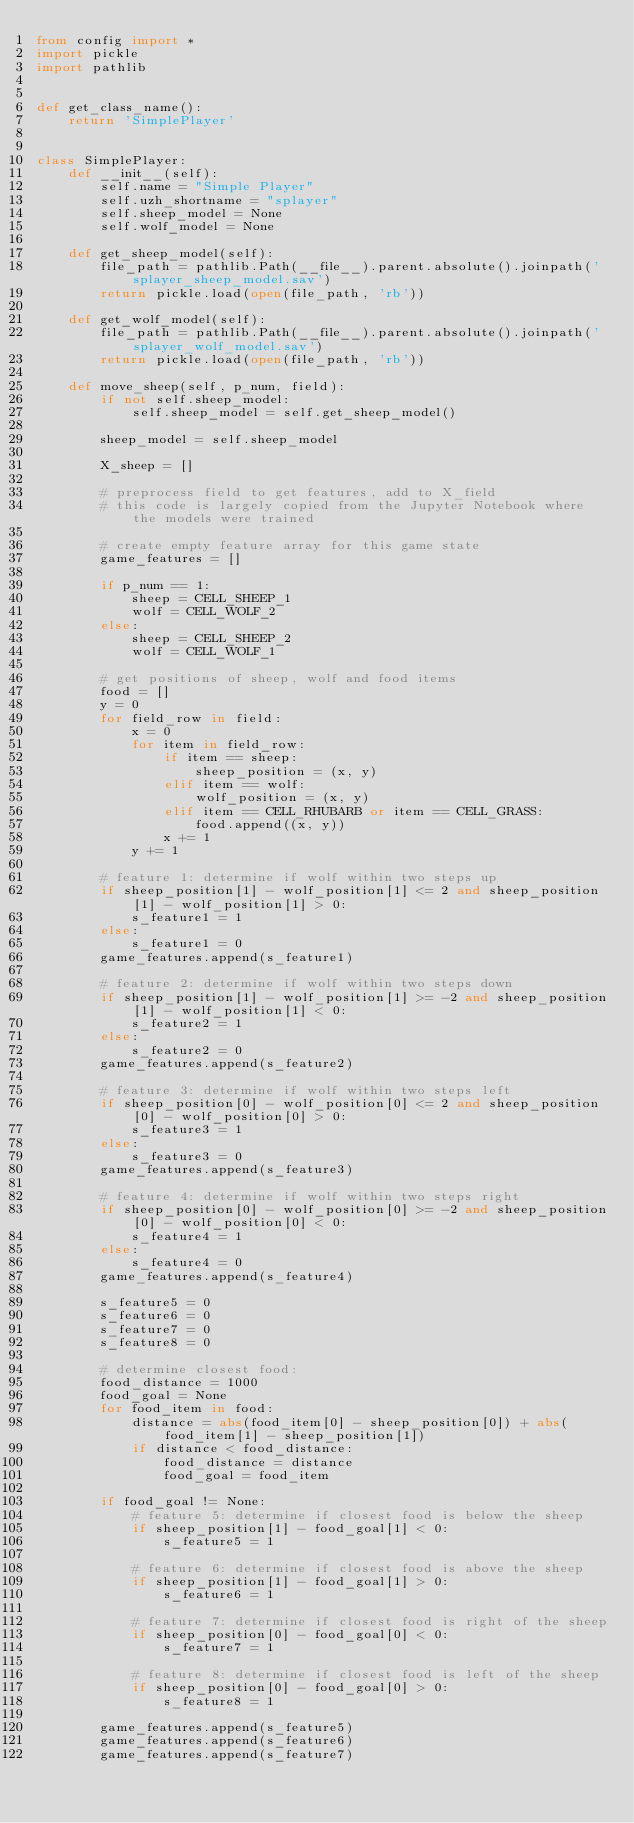Convert code to text. <code><loc_0><loc_0><loc_500><loc_500><_Python_>from config import *
import pickle
import pathlib


def get_class_name():
    return 'SimplePlayer'


class SimplePlayer:
    def __init__(self):
        self.name = "Simple Player"
        self.uzh_shortname = "splayer"
        self.sheep_model = None
        self.wolf_model = None

    def get_sheep_model(self):
        file_path = pathlib.Path(__file__).parent.absolute().joinpath('splayer_sheep_model.sav')
        return pickle.load(open(file_path, 'rb'))

    def get_wolf_model(self):
        file_path = pathlib.Path(__file__).parent.absolute().joinpath('splayer_wolf_model.sav')
        return pickle.load(open(file_path, 'rb'))

    def move_sheep(self, p_num, field):
        if not self.sheep_model:
            self.sheep_model = self.get_sheep_model()

        sheep_model = self.sheep_model

        X_sheep = []

        # preprocess field to get features, add to X_field
        # this code is largely copied from the Jupyter Notebook where the models were trained

        # create empty feature array for this game state
        game_features = []

        if p_num == 1:
            sheep = CELL_SHEEP_1
            wolf = CELL_WOLF_2
        else:
            sheep = CELL_SHEEP_2
            wolf = CELL_WOLF_1

        # get positions of sheep, wolf and food items
        food = []
        y = 0
        for field_row in field:
            x = 0
            for item in field_row:
                if item == sheep:
                    sheep_position = (x, y)
                elif item == wolf:
                    wolf_position = (x, y)
                elif item == CELL_RHUBARB or item == CELL_GRASS:
                    food.append((x, y))
                x += 1
            y += 1

        # feature 1: determine if wolf within two steps up
        if sheep_position[1] - wolf_position[1] <= 2 and sheep_position[1] - wolf_position[1] > 0:
            s_feature1 = 1
        else:
            s_feature1 = 0
        game_features.append(s_feature1)

        # feature 2: determine if wolf within two steps down
        if sheep_position[1] - wolf_position[1] >= -2 and sheep_position[1] - wolf_position[1] < 0:
            s_feature2 = 1
        else:
            s_feature2 = 0
        game_features.append(s_feature2)

        # feature 3: determine if wolf within two steps left
        if sheep_position[0] - wolf_position[0] <= 2 and sheep_position[0] - wolf_position[0] > 0:
            s_feature3 = 1
        else:
            s_feature3 = 0
        game_features.append(s_feature3)

        # feature 4: determine if wolf within two steps right
        if sheep_position[0] - wolf_position[0] >= -2 and sheep_position[0] - wolf_position[0] < 0:
            s_feature4 = 1
        else:
            s_feature4 = 0
        game_features.append(s_feature4)

        s_feature5 = 0
        s_feature6 = 0
        s_feature7 = 0
        s_feature8 = 0

        # determine closest food:
        food_distance = 1000
        food_goal = None
        for food_item in food:
            distance = abs(food_item[0] - sheep_position[0]) + abs(food_item[1] - sheep_position[1])
            if distance < food_distance:
                food_distance = distance
                food_goal = food_item

        if food_goal != None:
            # feature 5: determine if closest food is below the sheep
            if sheep_position[1] - food_goal[1] < 0:
                s_feature5 = 1

            # feature 6: determine if closest food is above the sheep
            if sheep_position[1] - food_goal[1] > 0:
                s_feature6 = 1

            # feature 7: determine if closest food is right of the sheep
            if sheep_position[0] - food_goal[0] < 0:
                s_feature7 = 1

            # feature 8: determine if closest food is left of the sheep
            if sheep_position[0] - food_goal[0] > 0:
                s_feature8 = 1

        game_features.append(s_feature5)
        game_features.append(s_feature6)
        game_features.append(s_feature7)</code> 